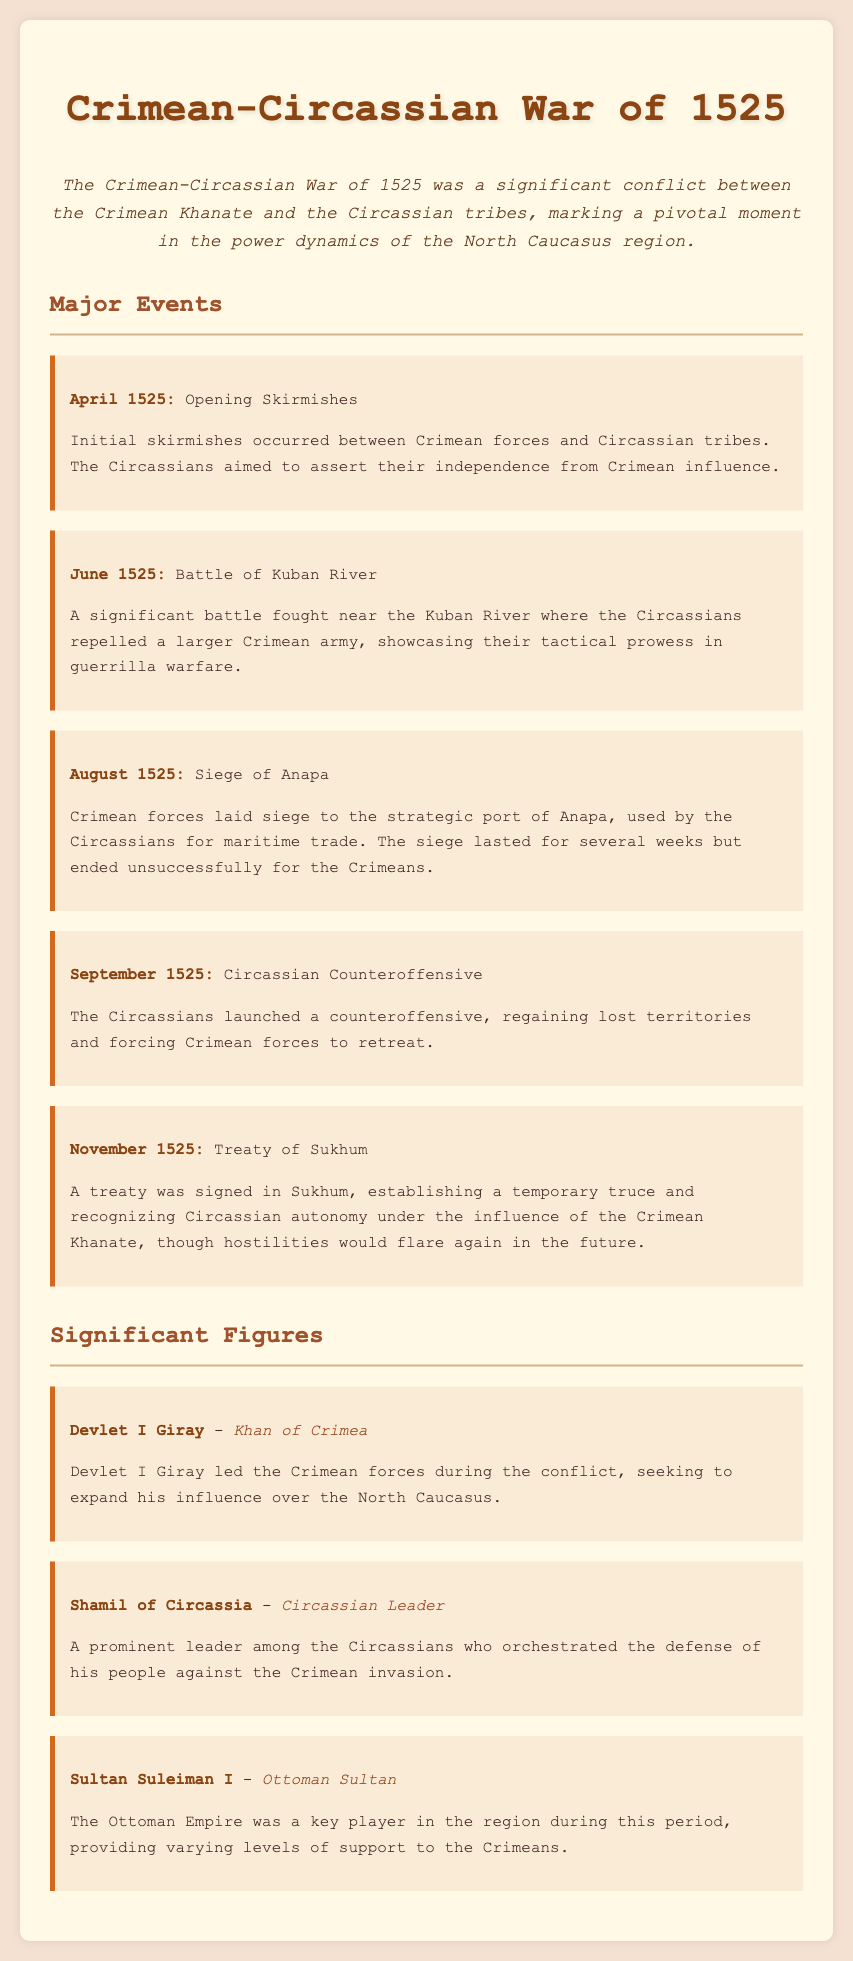What was the date of the Battle of Kuban River? The document explicitly states that the Battle of Kuban River took place in June 1525.
Answer: June 1525 Who was the Khan of Crimea during the war? The document identifies Devlet I Giray as the Khan of Crimea who led the forces during the conflict.
Answer: Devlet I Giray What significant event occurred in November 1525? According to the document, a treaty was signed in November 1525, which marks a significant event.
Answer: Treaty of Sukhum What was the main outcome of the Siege of Anapa? The document notes that the siege lasted for several weeks but ended unsuccessfully for the Crimeans, highlighting the outcome of this event.
Answer: Unsuccessfully for the Crimeans Who was Shamil of Circassia? The document describes Shamil of Circassia as a prominent leader who orchestrated the defense against the Crimean invasion.
Answer: Circassian Leader 